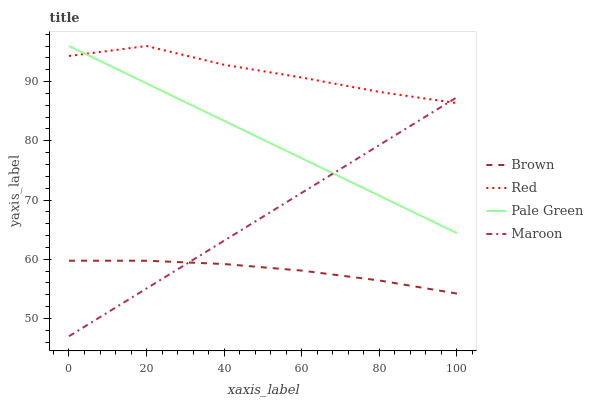Does Brown have the minimum area under the curve?
Answer yes or no. Yes. Does Red have the maximum area under the curve?
Answer yes or no. Yes. Does Pale Green have the minimum area under the curve?
Answer yes or no. No. Does Pale Green have the maximum area under the curve?
Answer yes or no. No. Is Maroon the smoothest?
Answer yes or no. Yes. Is Red the roughest?
Answer yes or no. Yes. Is Pale Green the smoothest?
Answer yes or no. No. Is Pale Green the roughest?
Answer yes or no. No. Does Pale Green have the lowest value?
Answer yes or no. No. Does Maroon have the highest value?
Answer yes or no. No. Is Brown less than Pale Green?
Answer yes or no. Yes. Is Red greater than Brown?
Answer yes or no. Yes. Does Brown intersect Pale Green?
Answer yes or no. No. 